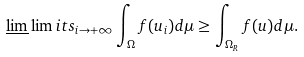Convert formula to latex. <formula><loc_0><loc_0><loc_500><loc_500>\underline { \lim } \lim i t s _ { i \rightarrow + \infty } \int _ { \Omega } f ( u _ { i } ) d \mu \geq \int _ { \Omega _ { R } } f ( u ) d \mu .</formula> 